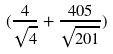Convert formula to latex. <formula><loc_0><loc_0><loc_500><loc_500>( \frac { 4 } { \sqrt { 4 } } + \frac { 4 0 5 } { \sqrt { 2 0 1 } } )</formula> 